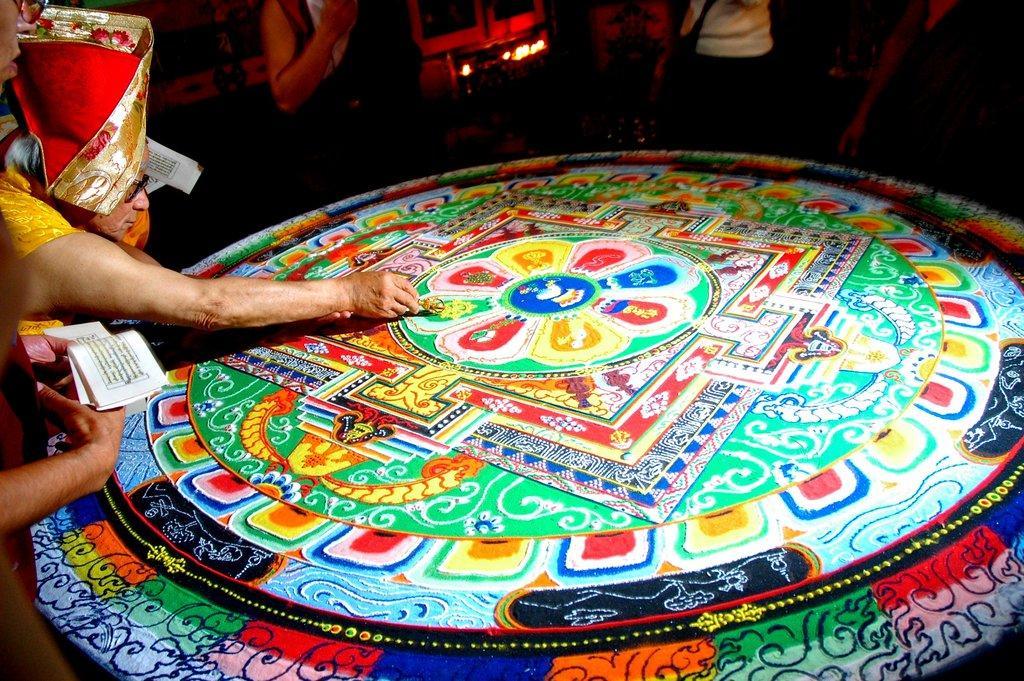Can you describe this image briefly? In the image in the center, we can see one table. On the table, we can see some paint work. In the background there is a wall, lights and few people are standing and holding some objects. 